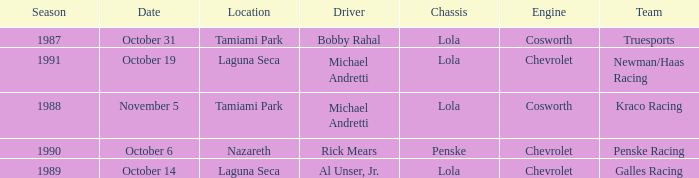Which team raced on October 19? Newman/Haas Racing. 